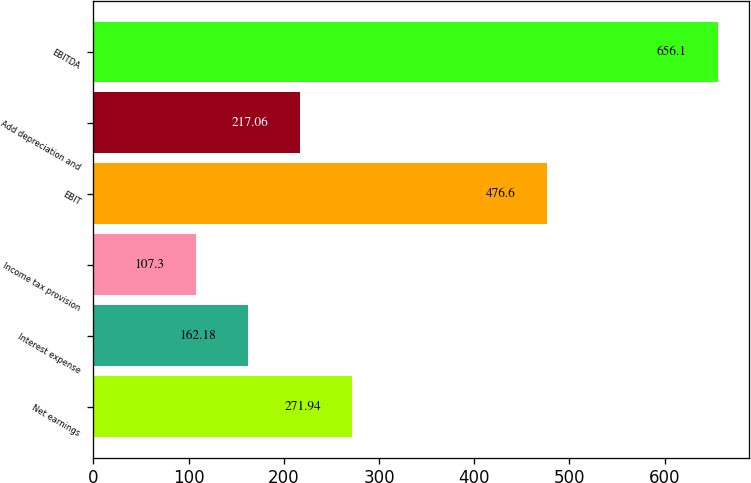<chart> <loc_0><loc_0><loc_500><loc_500><bar_chart><fcel>Net earnings<fcel>Interest expense<fcel>Income tax provision<fcel>EBIT<fcel>Add depreciation and<fcel>EBITDA<nl><fcel>271.94<fcel>162.18<fcel>107.3<fcel>476.6<fcel>217.06<fcel>656.1<nl></chart> 